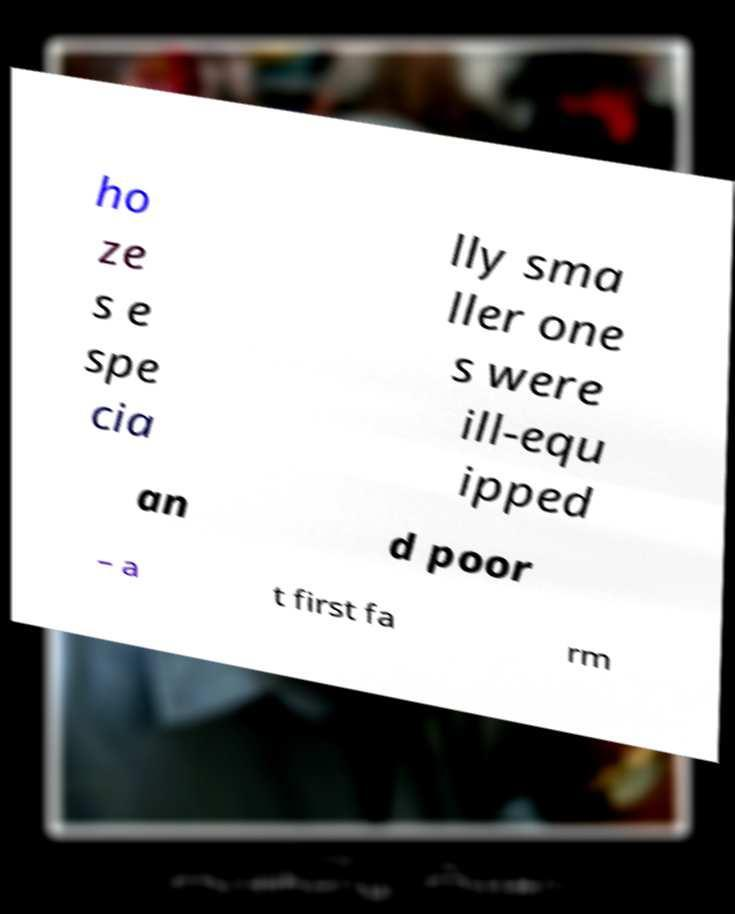Please read and relay the text visible in this image. What does it say? ho ze s e spe cia lly sma ller one s were ill-equ ipped an d poor – a t first fa rm 